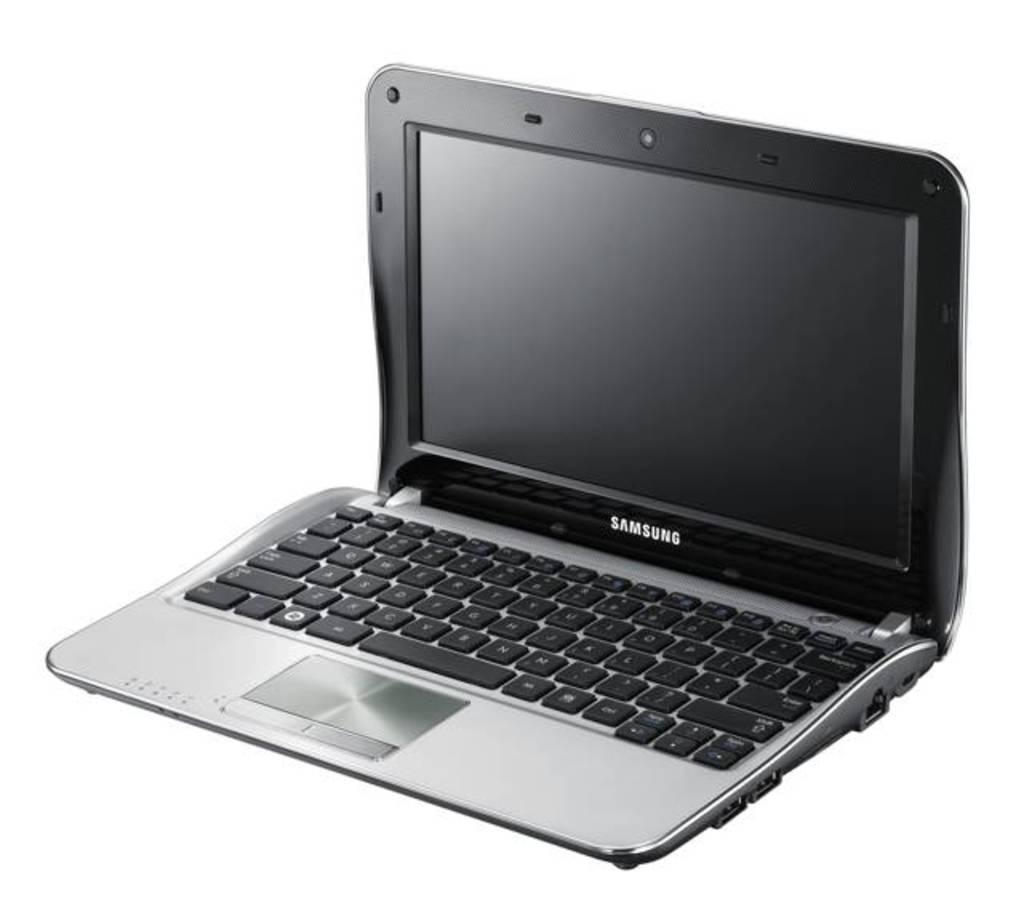<image>
Write a terse but informative summary of the picture. a display of a Samsung lap top computer 